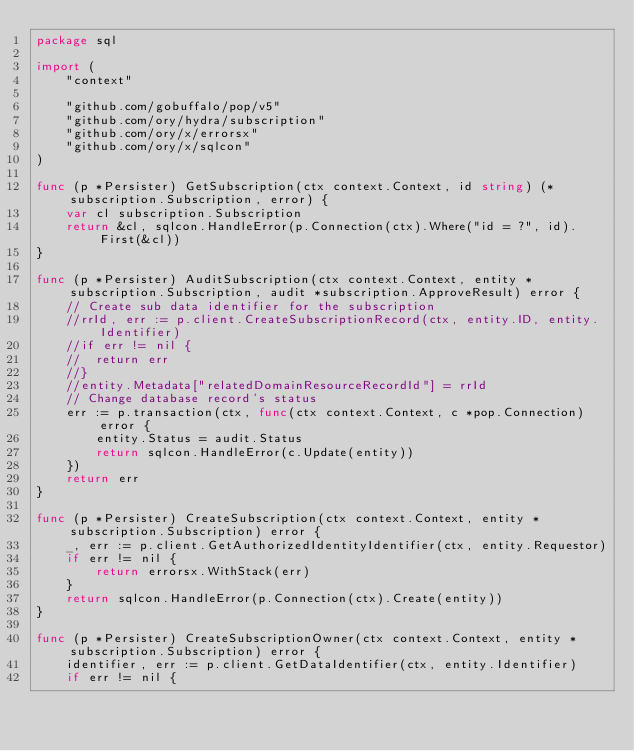<code> <loc_0><loc_0><loc_500><loc_500><_Go_>package sql

import (
	"context"

	"github.com/gobuffalo/pop/v5"
	"github.com/ory/hydra/subscription"
	"github.com/ory/x/errorsx"
	"github.com/ory/x/sqlcon"
)

func (p *Persister) GetSubscription(ctx context.Context, id string) (*subscription.Subscription, error) {
	var cl subscription.Subscription
	return &cl, sqlcon.HandleError(p.Connection(ctx).Where("id = ?", id).First(&cl))
}

func (p *Persister) AuditSubscription(ctx context.Context, entity *subscription.Subscription, audit *subscription.ApproveResult) error {
	// Create sub data identifier for the subscription
	//rrId, err := p.client.CreateSubscriptionRecord(ctx, entity.ID, entity.Identifier)
	//if err != nil {
	//	return err
	//}
	//entity.Metadata["relatedDomainResourceRecordId"] = rrId
	// Change database record's status
	err := p.transaction(ctx, func(ctx context.Context, c *pop.Connection) error {
		entity.Status = audit.Status
		return sqlcon.HandleError(c.Update(entity))
	})
	return err
}

func (p *Persister) CreateSubscription(ctx context.Context, entity *subscription.Subscription) error {
	_, err := p.client.GetAuthorizedIdentityIdentifier(ctx, entity.Requestor)
	if err != nil {
		return errorsx.WithStack(err)
	}
	return sqlcon.HandleError(p.Connection(ctx).Create(entity))
}

func (p *Persister) CreateSubscriptionOwner(ctx context.Context, entity *subscription.Subscription) error {
	identifier, err := p.client.GetDataIdentifier(ctx, entity.Identifier)
	if err != nil {</code> 